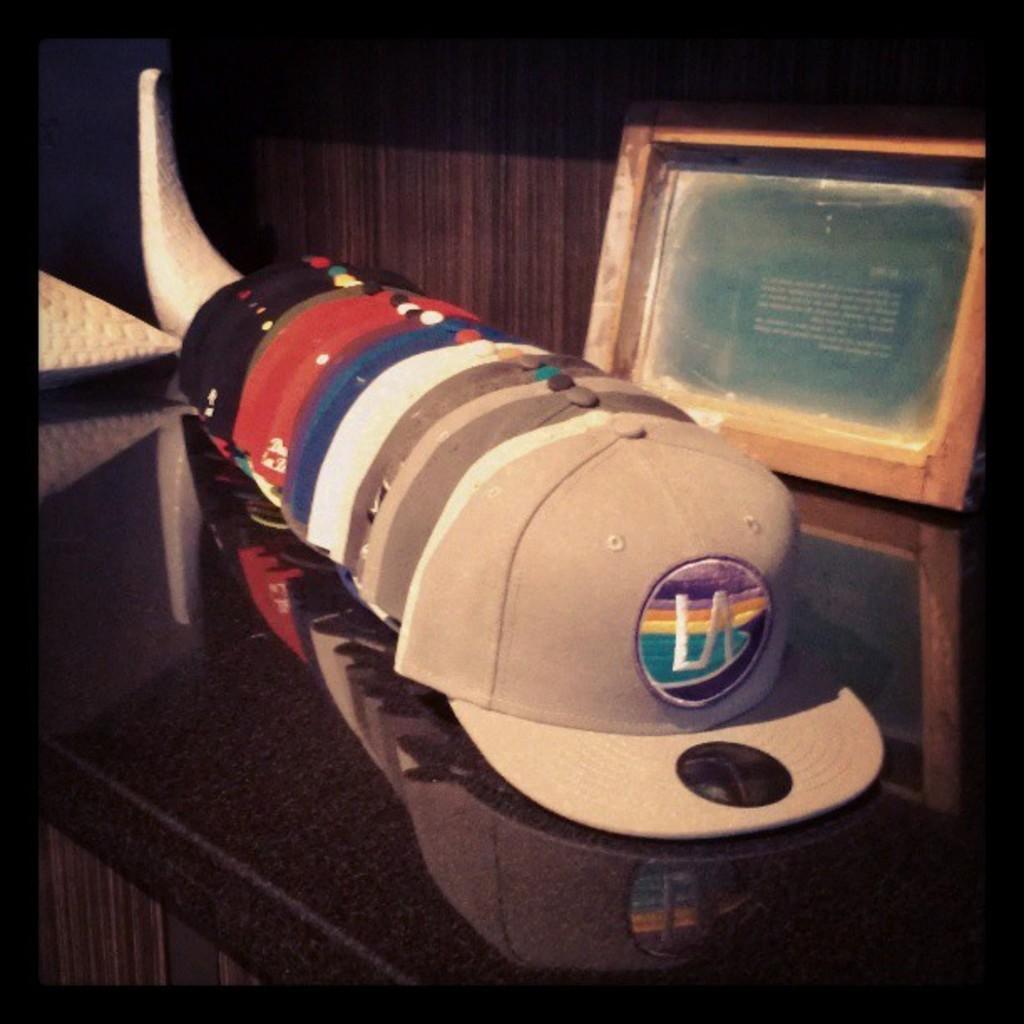Describe this image in one or two sentences. In this image we can see few caps and a photo frame on the table and the background looks like the wall. 